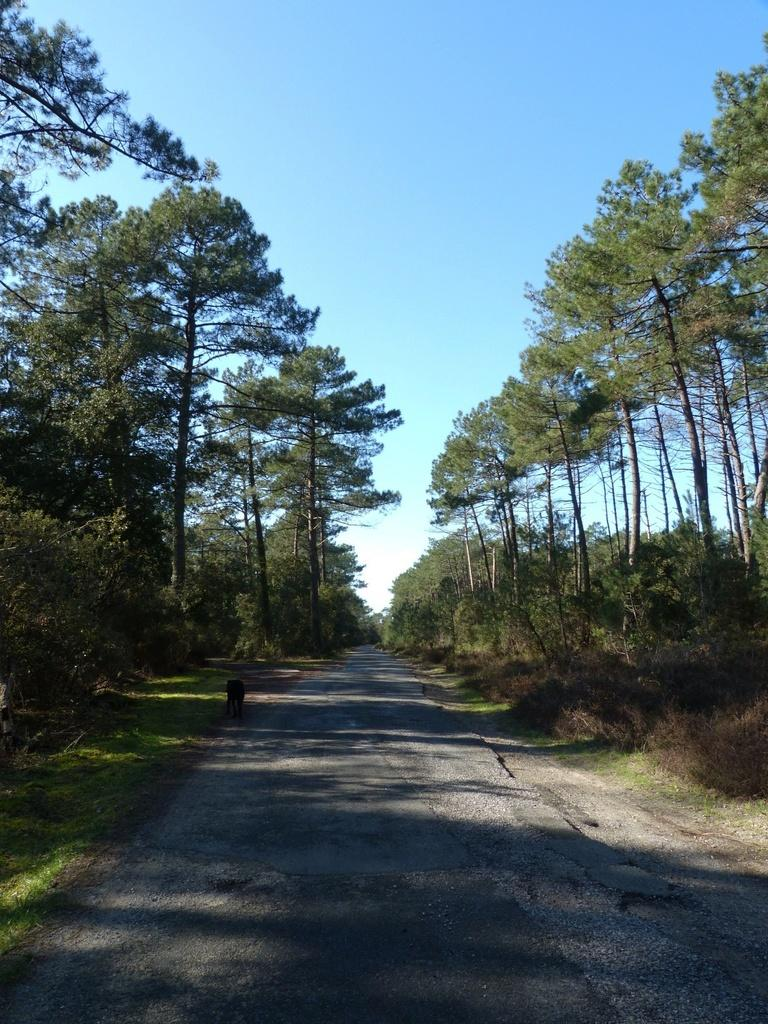Where was the image taken? The image was clicked outside. What can be seen in the middle of the image? There are trees and a road in the middle of the image. What is visible at the top of the image? The sky is visible at the top of the image. What is the purpose of the stomach in the image? There is no stomach present in the image. What reason might someone have for walking on the road in the image? The image does not depict anyone walking on the road, so we cannot determine the reason for doing so. 